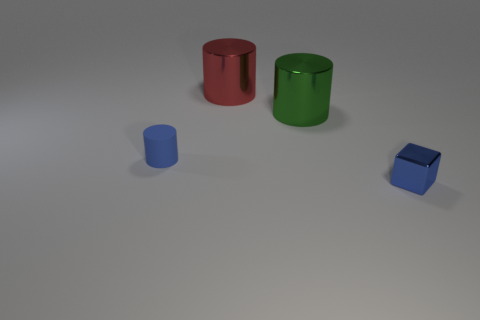Is there anything else that is made of the same material as the blue cylinder?
Your answer should be very brief. No. What is the color of the rubber thing?
Provide a short and direct response. Blue. Do the small matte object and the metal block have the same color?
Your response must be concise. Yes. What number of metallic things are either big red cylinders or big green things?
Ensure brevity in your answer.  2. There is a small blue object that is to the left of the tiny metal block in front of the rubber object; are there any green metallic objects to the left of it?
Provide a succinct answer. No. There is a red thing that is the same material as the cube; what size is it?
Your answer should be compact. Large. There is a large green cylinder; are there any cubes right of it?
Provide a succinct answer. Yes. There is a object left of the red metallic cylinder; is there a red thing that is in front of it?
Provide a succinct answer. No. Is the size of the green cylinder that is behind the tiny blue metallic object the same as the metal thing in front of the tiny blue cylinder?
Your answer should be very brief. No. How many big objects are either metallic cylinders or green objects?
Give a very brief answer. 2. 